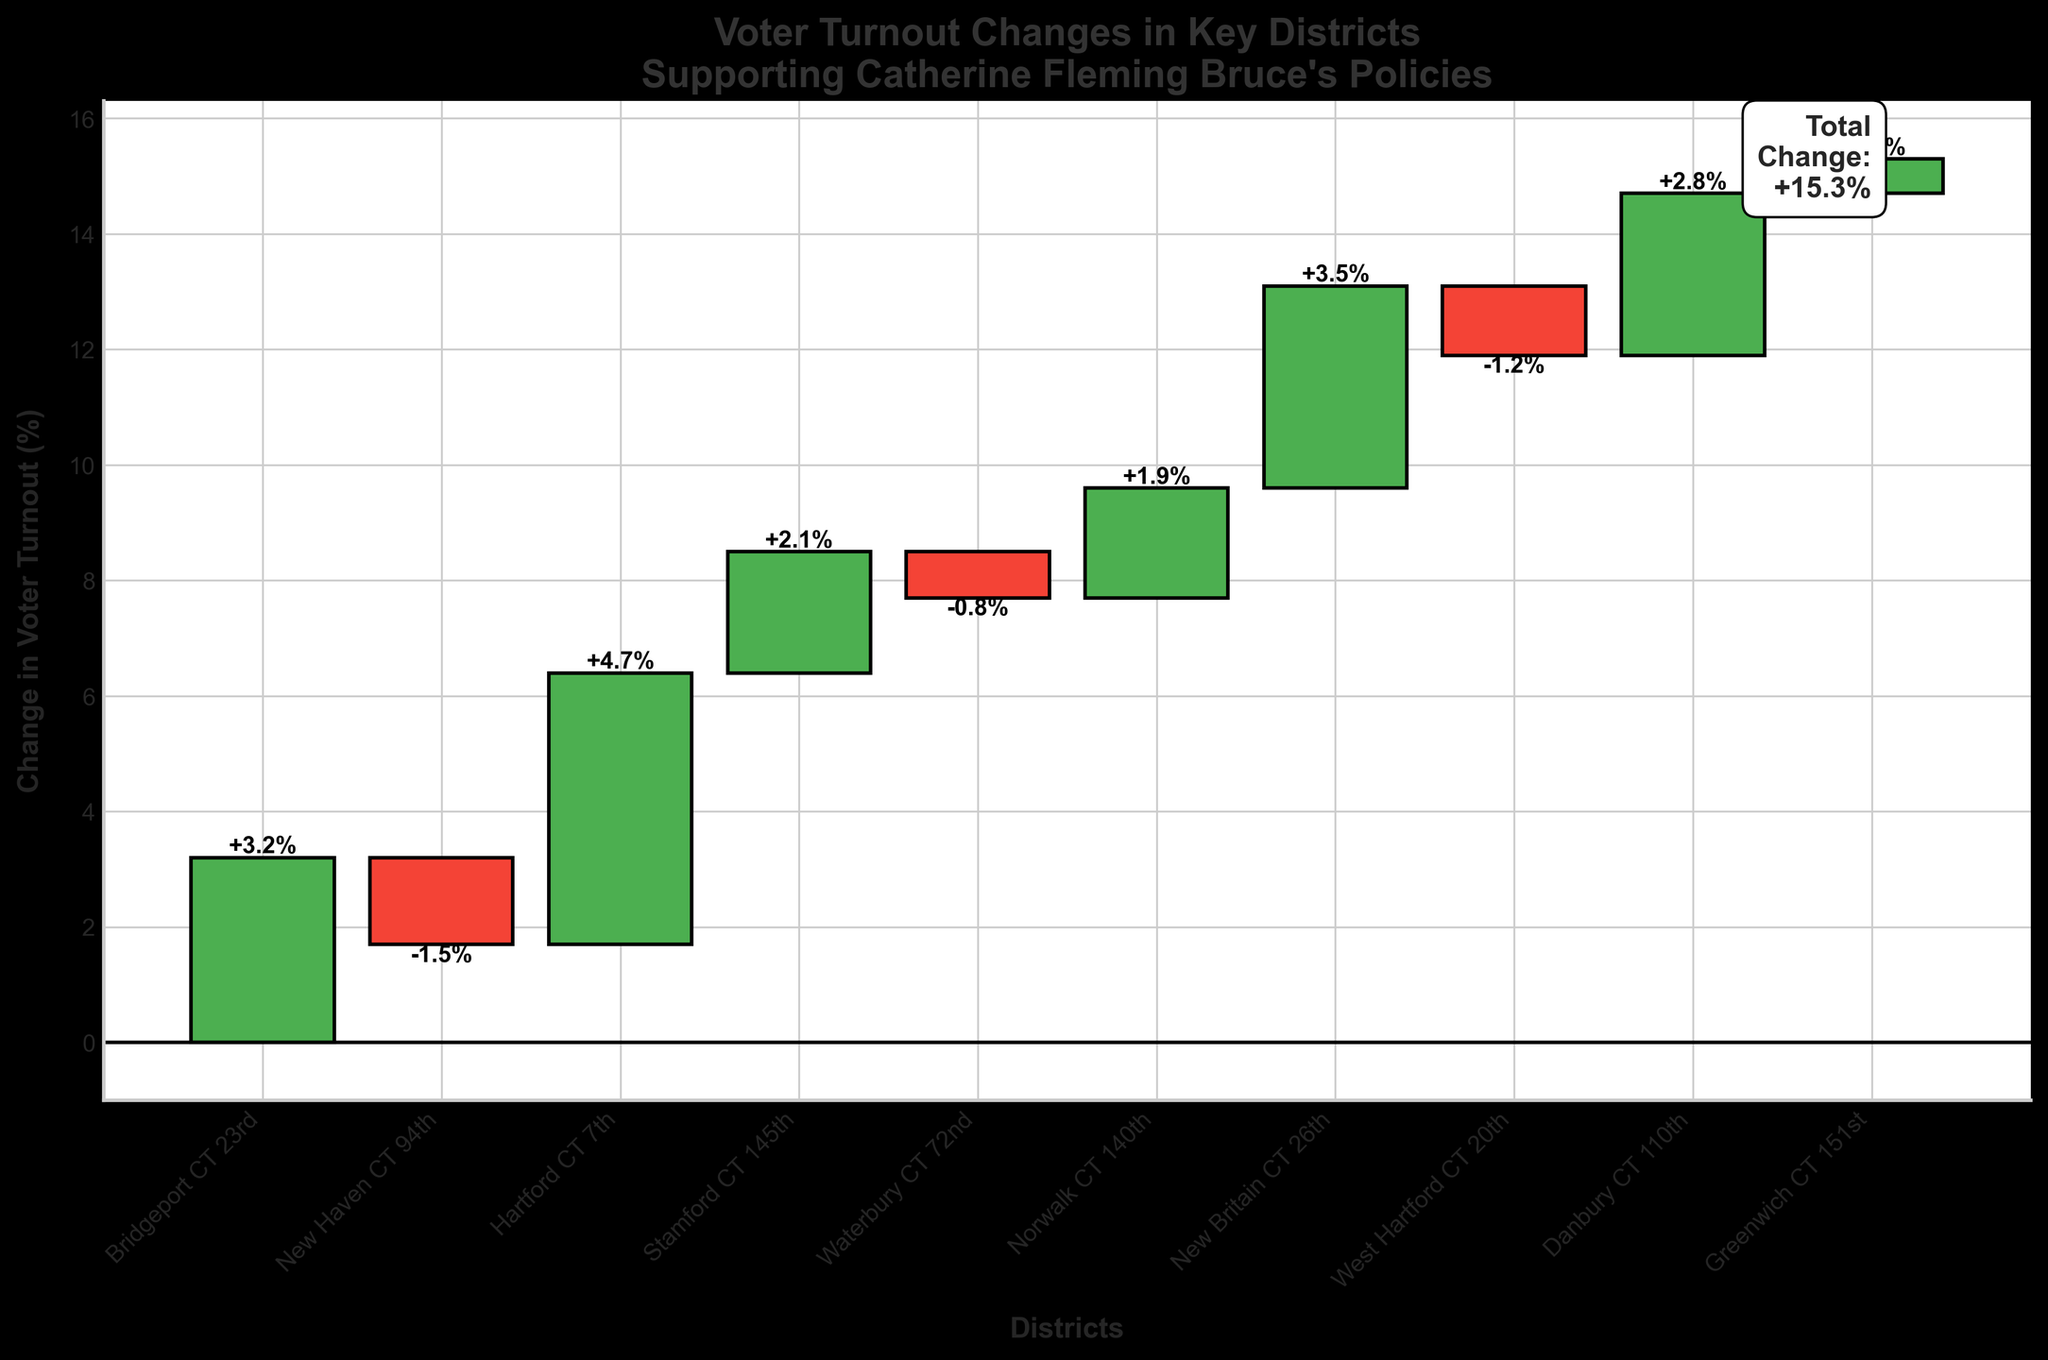How many districts show a positive change in voter turnout? From the chart, districts with bars above the baseline have a positive change. Count these districts.
Answer: 6 Which district has the largest increase in voter turnout? Identify the district with the tallest bar above the baseline.
Answer: Hartford CT 7th What is the total voter turnout change across all districts? Refer to the annotation at the end of the chart highlighting total change.
Answer: +15.3% Which districts show a negative change in voter turnout? Identify districts with bars below the baseline by examining the direction of the bars.
Answer: New Haven CT 94th, Waterbury CT 72nd, West Hartford CT 20th Between New Britain CT 26th and Danbury CT 110th, which district had a higher voter turnout change? Compare the height of bars for these two districts.
Answer: New Britain CT 26th What is the cumulative voter turnout change for the first three districts? Sum the voter turnout changes for Bridgeport CT 23rd, New Haven CT 94th, and Hartford CT 7th. Calculation: (+3.2) + (-1.5) + (+4.7) = +6.4%
Answer: +6.4% What is the voter turnout change for Stamford CT 145th? Find the specific bar for Stamford CT 145th and read the annotated value.
Answer: +2.1% How many districts have a voter turnout change of 2% or more? Review the height of bars and count those with a change of 2% or greater.
Answer: 4 Which district had the smallest positive change in voter turnout? Identify the smallest bar above the baseline among positive changes.
Answer: Greenwich CT 151st Is the voter turnout change in New Haven CT 94th increase or decrease? Check the orientation of the bar for New Haven CT 94th to see if it is above or below the baseline.
Answer: Decrease 